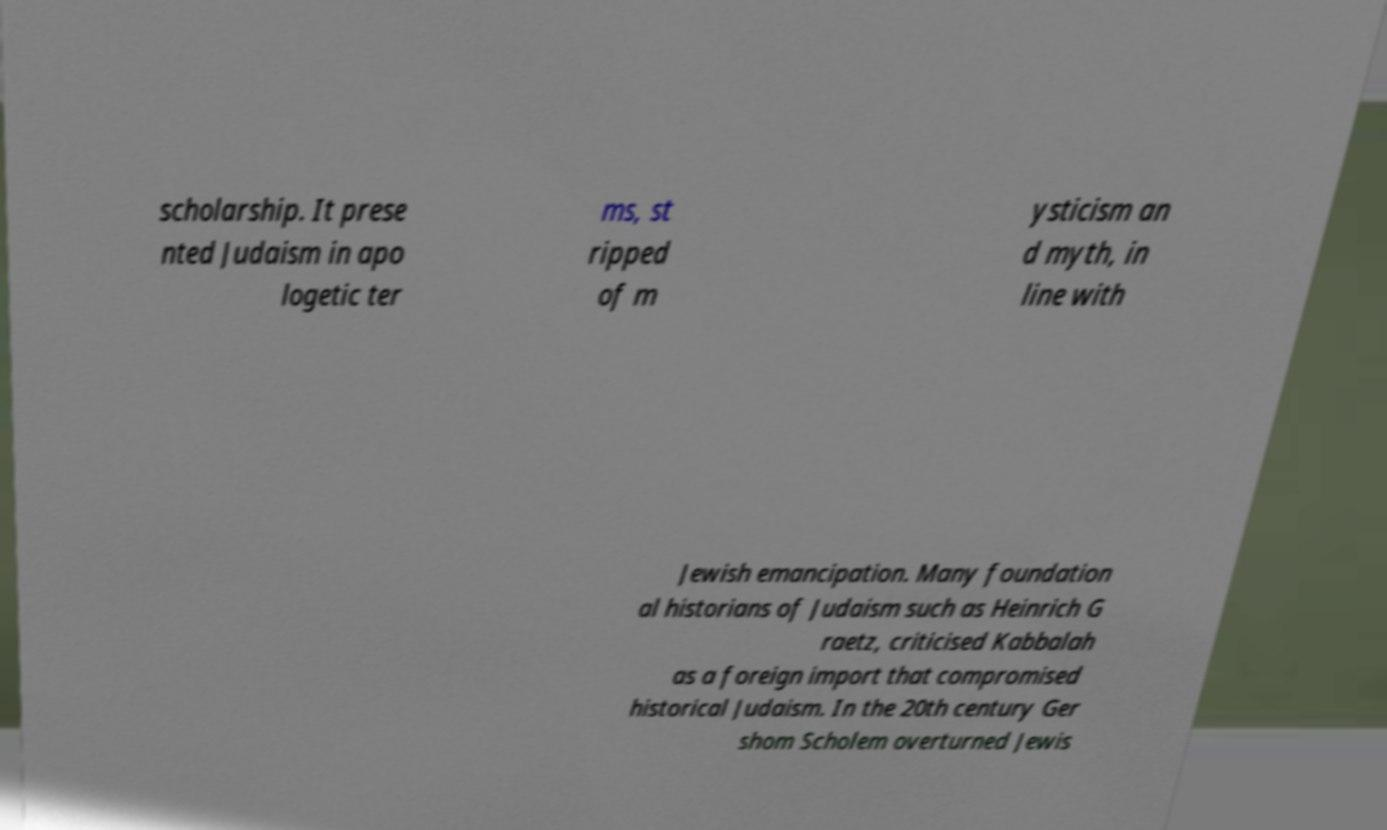Please read and relay the text visible in this image. What does it say? scholarship. It prese nted Judaism in apo logetic ter ms, st ripped of m ysticism an d myth, in line with Jewish emancipation. Many foundation al historians of Judaism such as Heinrich G raetz, criticised Kabbalah as a foreign import that compromised historical Judaism. In the 20th century Ger shom Scholem overturned Jewis 